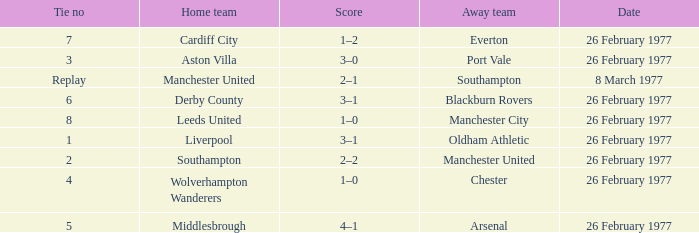What's the score when the Wolverhampton Wanderers played at home? 1–0. 